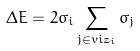<formula> <loc_0><loc_0><loc_500><loc_500>\Delta E = 2 \sigma _ { i } \sum _ { j \in v i z _ { i } } \sigma _ { j }</formula> 